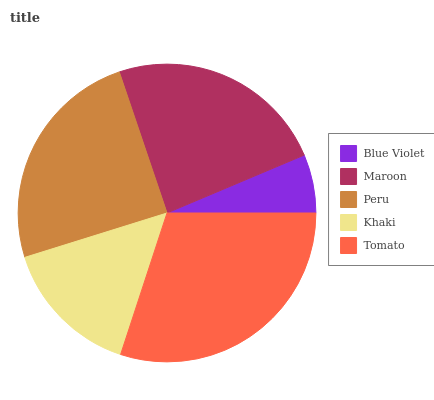Is Blue Violet the minimum?
Answer yes or no. Yes. Is Tomato the maximum?
Answer yes or no. Yes. Is Maroon the minimum?
Answer yes or no. No. Is Maroon the maximum?
Answer yes or no. No. Is Maroon greater than Blue Violet?
Answer yes or no. Yes. Is Blue Violet less than Maroon?
Answer yes or no. Yes. Is Blue Violet greater than Maroon?
Answer yes or no. No. Is Maroon less than Blue Violet?
Answer yes or no. No. Is Maroon the high median?
Answer yes or no. Yes. Is Maroon the low median?
Answer yes or no. Yes. Is Tomato the high median?
Answer yes or no. No. Is Khaki the low median?
Answer yes or no. No. 